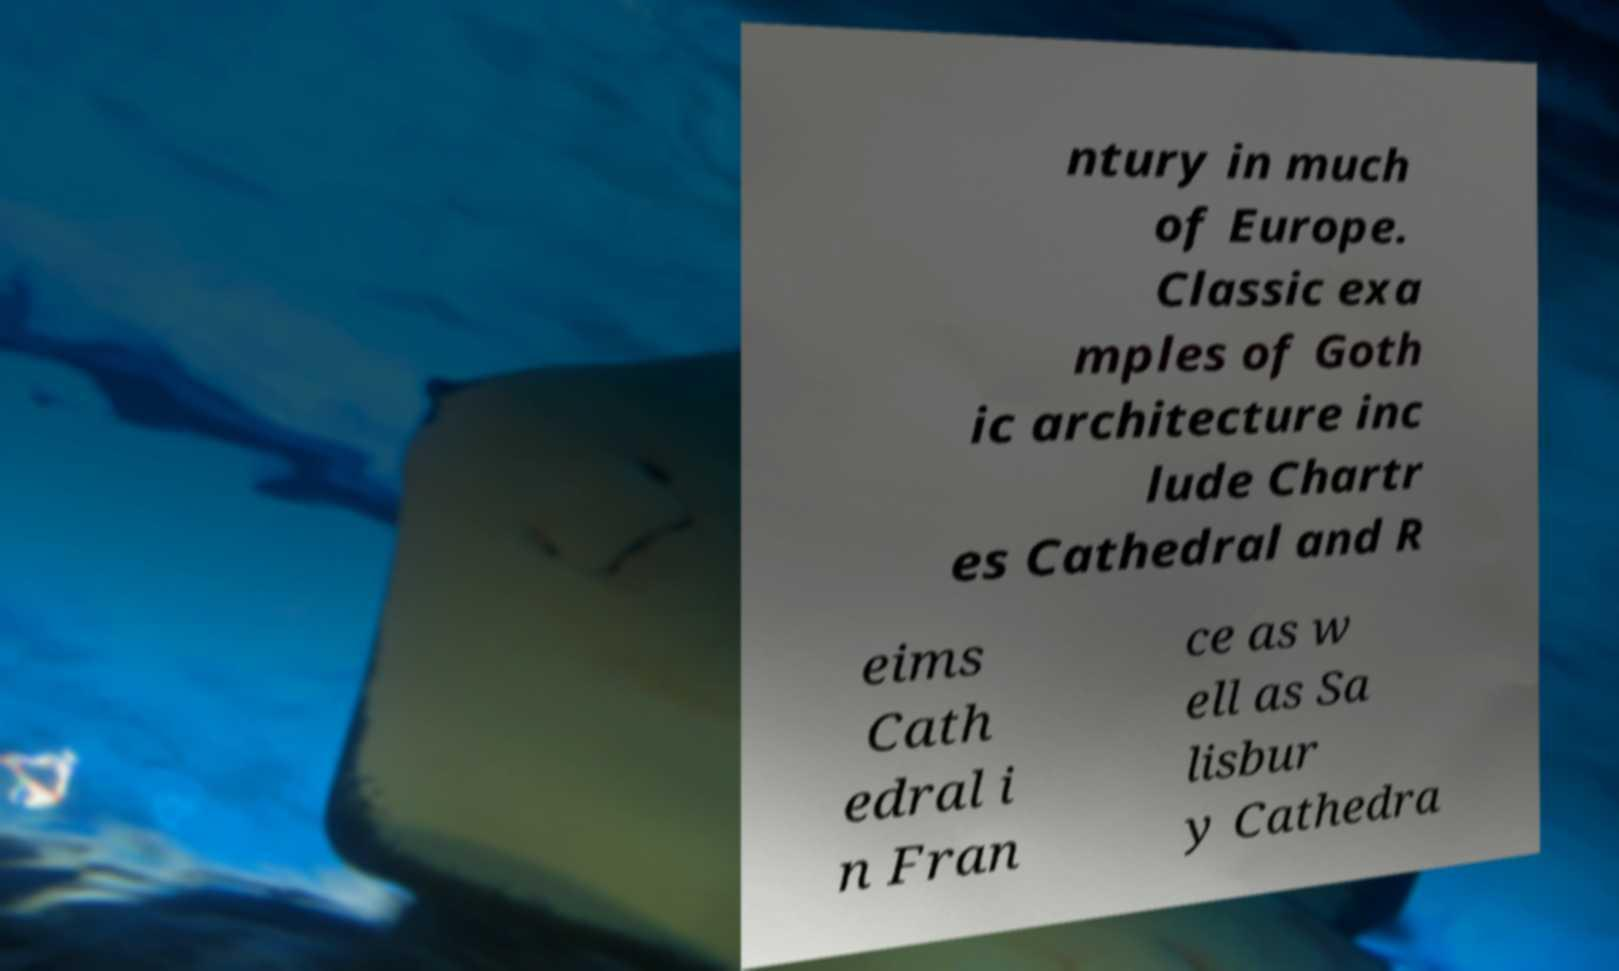Can you accurately transcribe the text from the provided image for me? ntury in much of Europe. Classic exa mples of Goth ic architecture inc lude Chartr es Cathedral and R eims Cath edral i n Fran ce as w ell as Sa lisbur y Cathedra 